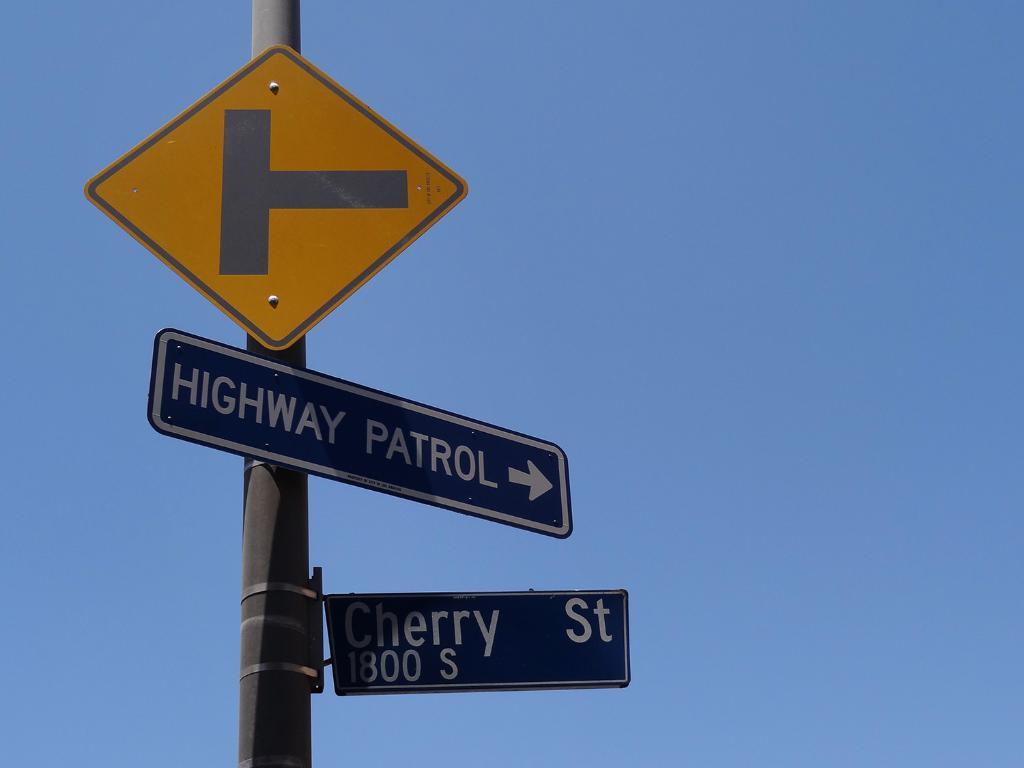What street does the sign indicate?
Give a very brief answer. Cherry st. What patrol does the sign mention?
Your answer should be very brief. Highway patrol. 